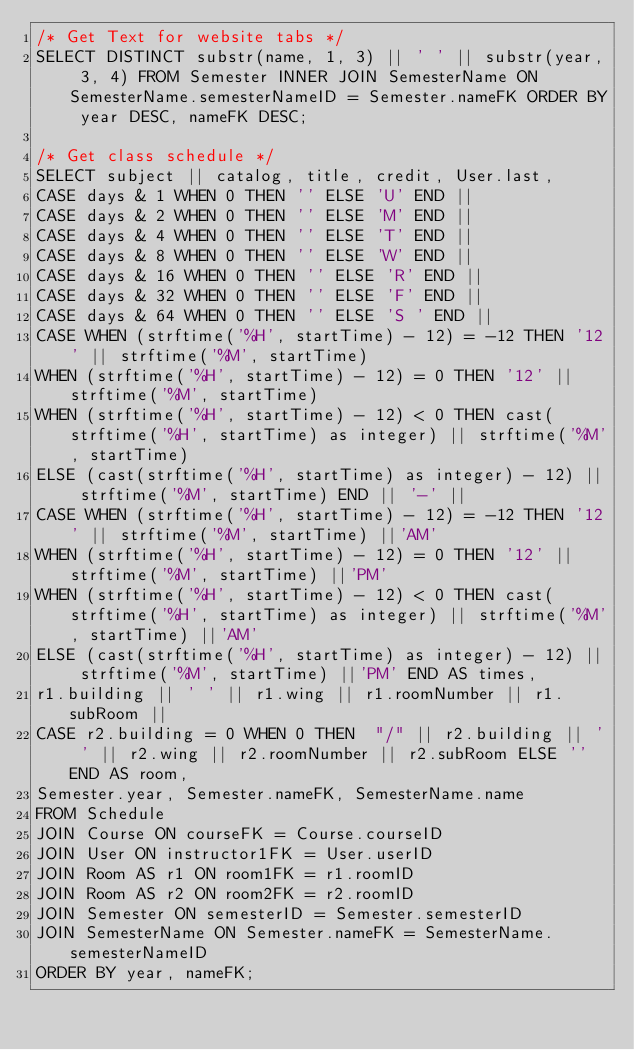Convert code to text. <code><loc_0><loc_0><loc_500><loc_500><_SQL_>/* Get Text for website tabs */
SELECT DISTINCT substr(name, 1, 3) || ' ' || substr(year, 3, 4) FROM Semester INNER JOIN SemesterName ON SemesterName.semesterNameID = Semester.nameFK ORDER BY year DESC, nameFK DESC;

/* Get class schedule */
SELECT subject || catalog, title, credit, User.last,
CASE days & 1 WHEN 0 THEN '' ELSE 'U' END ||
CASE days & 2 WHEN 0 THEN '' ELSE 'M' END ||
CASE days & 4 WHEN 0 THEN '' ELSE 'T' END ||
CASE days & 8 WHEN 0 THEN '' ELSE 'W' END ||
CASE days & 16 WHEN 0 THEN '' ELSE 'R' END ||
CASE days & 32 WHEN 0 THEN '' ELSE 'F' END ||
CASE days & 64 WHEN 0 THEN '' ELSE 'S ' END ||
CASE WHEN (strftime('%H', startTime) - 12) = -12 THEN '12' || strftime('%M', startTime) 
WHEN (strftime('%H', startTime) - 12) = 0 THEN '12' || strftime('%M', startTime)
WHEN (strftime('%H', startTime) - 12) < 0 THEN cast(strftime('%H', startTime) as integer) || strftime('%M', startTime)
ELSE (cast(strftime('%H', startTime) as integer) - 12) || strftime('%M', startTime) END || '-' ||
CASE WHEN (strftime('%H', startTime) - 12) = -12 THEN '12' || strftime('%M', startTime) ||'AM'
WHEN (strftime('%H', startTime) - 12) = 0 THEN '12' || strftime('%M', startTime) ||'PM'
WHEN (strftime('%H', startTime) - 12) < 0 THEN cast(strftime('%H', startTime) as integer) || strftime('%M', startTime) ||'AM'
ELSE (cast(strftime('%H', startTime) as integer) - 12) || strftime('%M', startTime) ||'PM' END AS times,
r1.building || ' ' || r1.wing || r1.roomNumber || r1.subRoom ||
CASE r2.building = 0 WHEN 0 THEN  "/" || r2.building || ' ' || r2.wing || r2.roomNumber || r2.subRoom ELSE '' END AS room,
Semester.year, Semester.nameFK, SemesterName.name
FROM Schedule
JOIN Course ON courseFK = Course.courseID 
JOIN User ON instructor1FK = User.userID
JOIN Room AS r1 ON room1FK = r1.roomID
JOIN Room AS r2 ON room2FK = r2.roomID
JOIN Semester ON semesterID = Semester.semesterID
JOIN SemesterName ON Semester.nameFK = SemesterName.semesterNameID
ORDER BY year, nameFK;</code> 